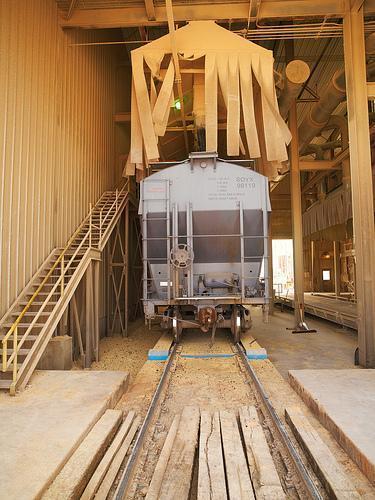How many blue blocks are there in front of the train?
Give a very brief answer. 3. How many steps on the train's ladder?
Give a very brief answer. 7. 